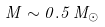<formula> <loc_0><loc_0><loc_500><loc_500>M \sim 0 . 5 \, M _ { \odot }</formula> 